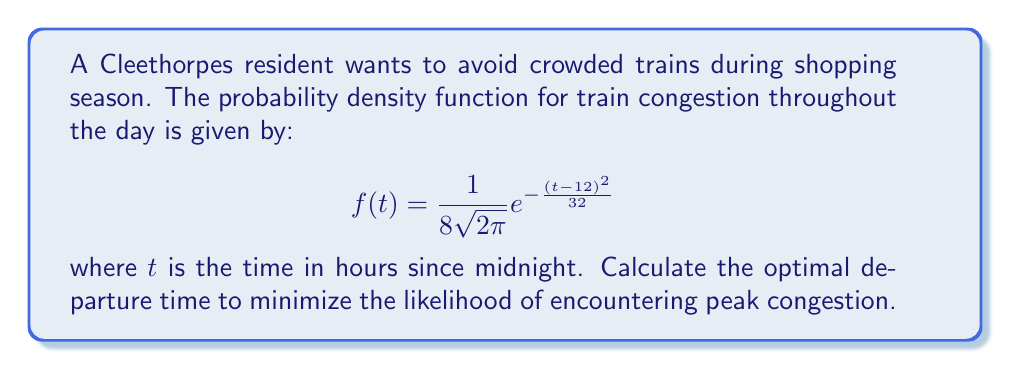Give your solution to this math problem. To find the optimal departure time, we need to determine the time when train congestion is at its minimum. This occurs at the point where the probability density function $f(t)$ is at its minimum.

Step 1: The given probability density function is a Gaussian (normal) distribution with mean $\mu = 12$ and variance $\sigma^2 = 16$.

Step 2: For a Gaussian distribution, the peak (maximum) occurs at the mean. Since we want to minimize congestion, we need to find the time furthest from the mean.

Step 3: The function is symmetric around the mean (12:00). The two points furthest from 12:00 within a 24-hour period are 0:00 (midnight) and 24:00 (also midnight).

Step 4: To verify, we can calculate $f(0)$ and $f(24)$:

$$f(0) = f(24) = \frac{1}{8\sqrt{2\pi}} e^{-\frac{(0-12)^2}{32}} = \frac{1}{8\sqrt{2\pi}} e^{-\frac{144}{32}} \approx 0.0038$$

This is indeed the minimum value of $f(t)$ over the 24-hour period.

Step 5: Therefore, the optimal departure time to minimize the likelihood of encountering peak congestion is either 0:00 (midnight) or any time very close to midnight.
Answer: 0:00 (midnight) 